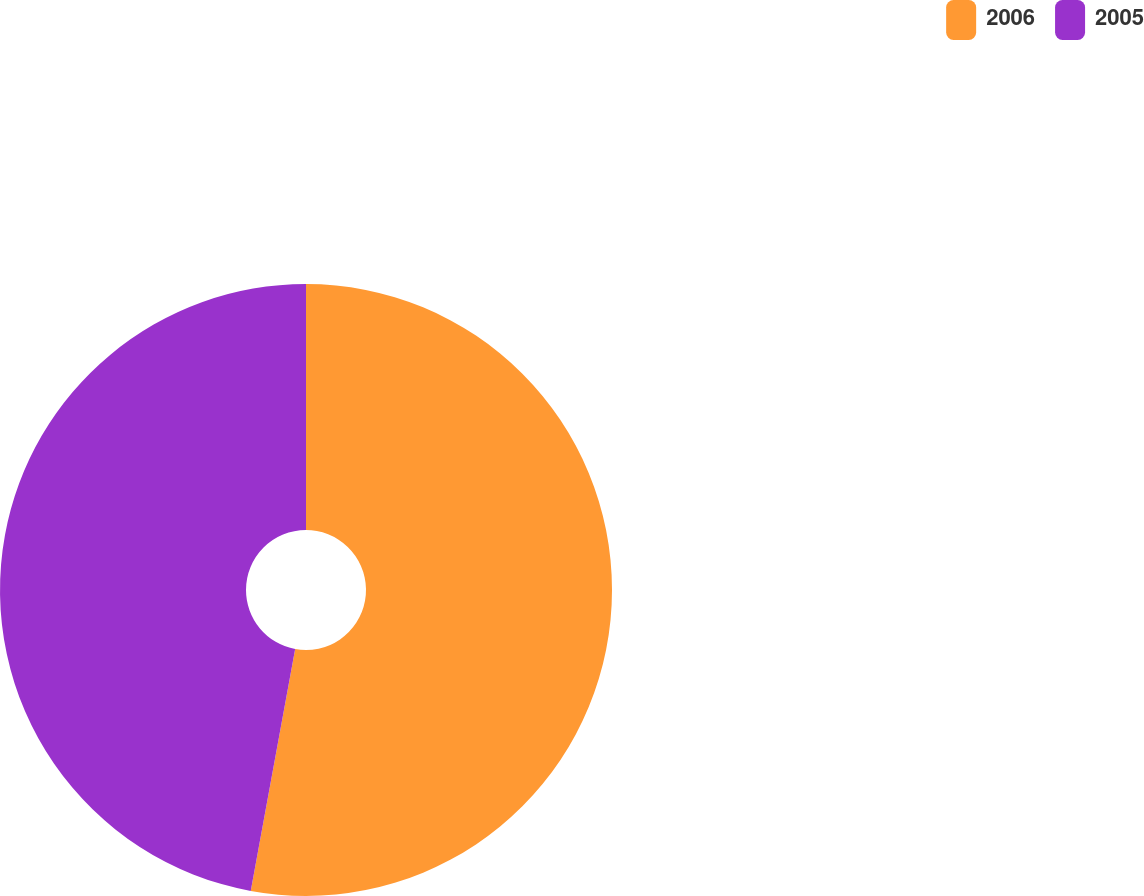Convert chart. <chart><loc_0><loc_0><loc_500><loc_500><pie_chart><fcel>2006<fcel>2005<nl><fcel>52.89%<fcel>47.11%<nl></chart> 